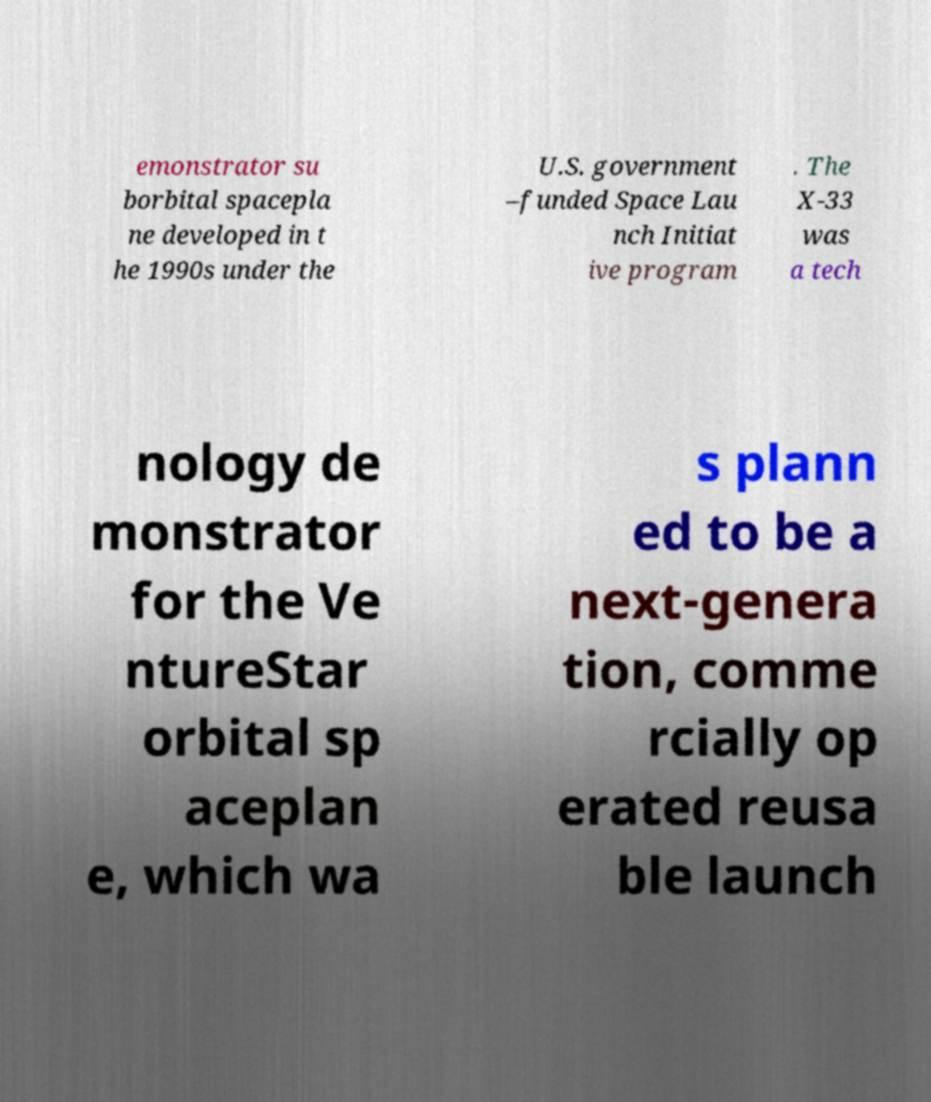Please identify and transcribe the text found in this image. emonstrator su borbital spacepla ne developed in t he 1990s under the U.S. government –funded Space Lau nch Initiat ive program . The X-33 was a tech nology de monstrator for the Ve ntureStar orbital sp aceplan e, which wa s plann ed to be a next-genera tion, comme rcially op erated reusa ble launch 